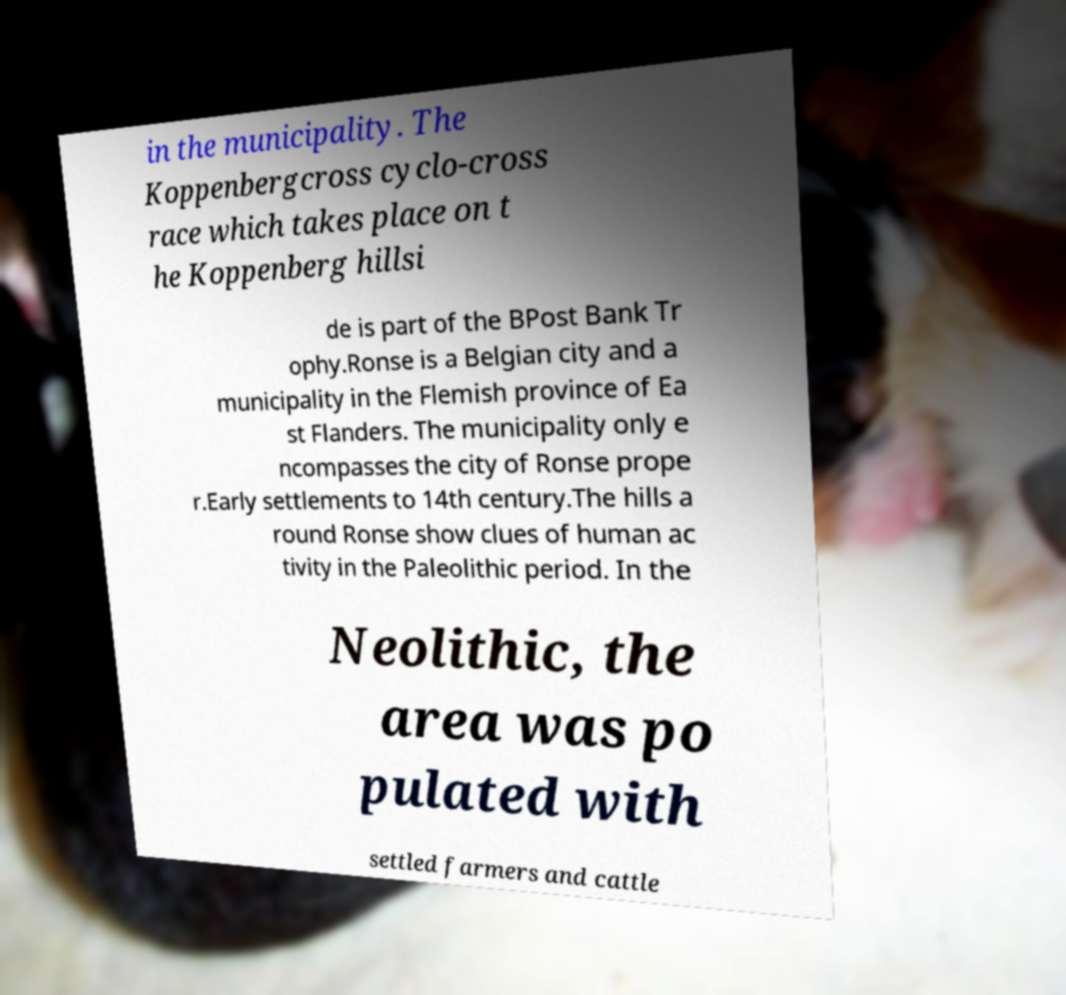Could you assist in decoding the text presented in this image and type it out clearly? in the municipality. The Koppenbergcross cyclo-cross race which takes place on t he Koppenberg hillsi de is part of the BPost Bank Tr ophy.Ronse is a Belgian city and a municipality in the Flemish province of Ea st Flanders. The municipality only e ncompasses the city of Ronse prope r.Early settlements to 14th century.The hills a round Ronse show clues of human ac tivity in the Paleolithic period. In the Neolithic, the area was po pulated with settled farmers and cattle 